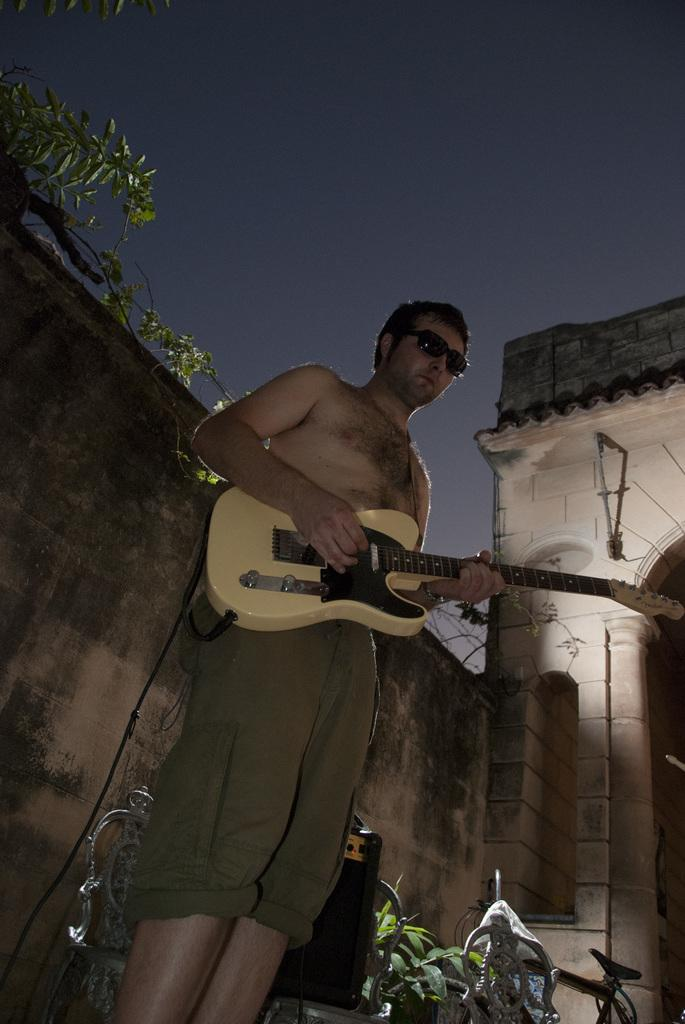What is the man in the image doing? The man is standing and playing a guitar. What other object can be seen in the image besides the man and his guitar? There is a bicycle in the image. What might indicate that this is a public or shared space? The presence of empty chairs suggests that this could be a public or shared space. What type of vegetation is visible in the image? There are small plants in the image. What type of structure is visible in the background? There is a building in the image. What type of headwear is the man wearing while playing the guitar? The man is not wearing any headwear while playing the guitar in the image. What type of stick can be seen in the image? There is no stick present in the image. 